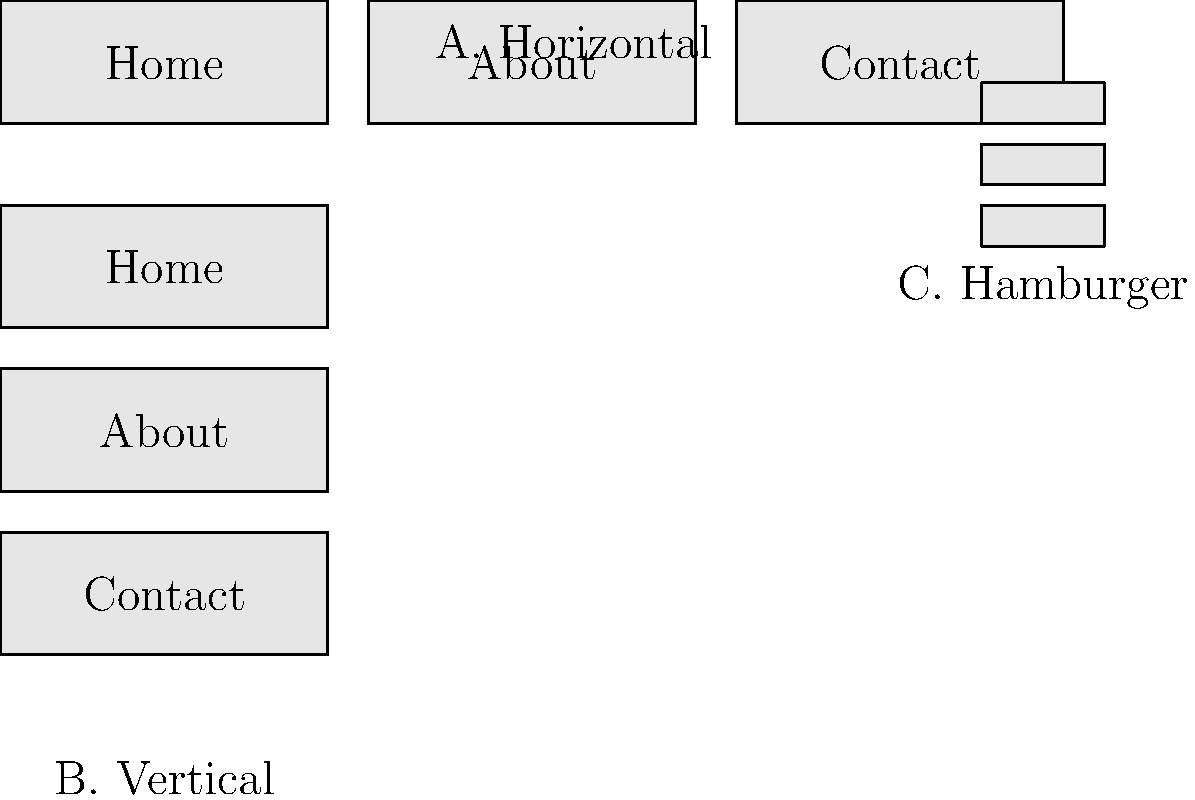Based on the wireframe mockup showing different navigation menu layouts, which option would you recommend for a responsive website that needs to maintain optimal performance on both desktop and mobile devices while providing an intuitive user experience? To answer this question, we need to consider several factors:

1. Responsiveness: The menu should adapt well to different screen sizes.
2. Performance: The chosen layout should not significantly impact server or UI performance.
3. User Experience: The navigation should be intuitive and easy to use across devices.

Let's analyze each option:

A. Horizontal Menu:
   - Pros: Clean, intuitive for desktop users
   - Cons: May not scale well for mobile devices or many menu items

B. Vertical Menu:
   - Pros: Can accommodate more items, works on both desktop and mobile
   - Cons: Takes up more vertical space, may require scrolling

C. Hamburger Menu:
   - Pros: Space-efficient, works well on mobile devices
   - Cons: Less discoverable, requires an extra click to access

Considering the need for responsiveness and performance:

1. The hamburger menu (C) is the most versatile option, as it adapts well to both desktop and mobile layouts.
2. It has minimal impact on initial page load performance, as menu items are hidden by default.
3. While it requires an extra click, it's become a widely recognized pattern for navigation, especially on mobile devices.
4. For desktop views, it can be combined with a horizontal menu for improved discoverability.

This solution balances UI and server performance by:
- Reducing initial page load time
- Minimizing the amount of content rendered on page load
- Providing a consistent experience across devices

While it may not be the most intuitive for all users, its widespread adoption has increased user familiarity, making it a solid choice for responsive design.
Answer: Hamburger menu (C) with optional horizontal menu for desktop 